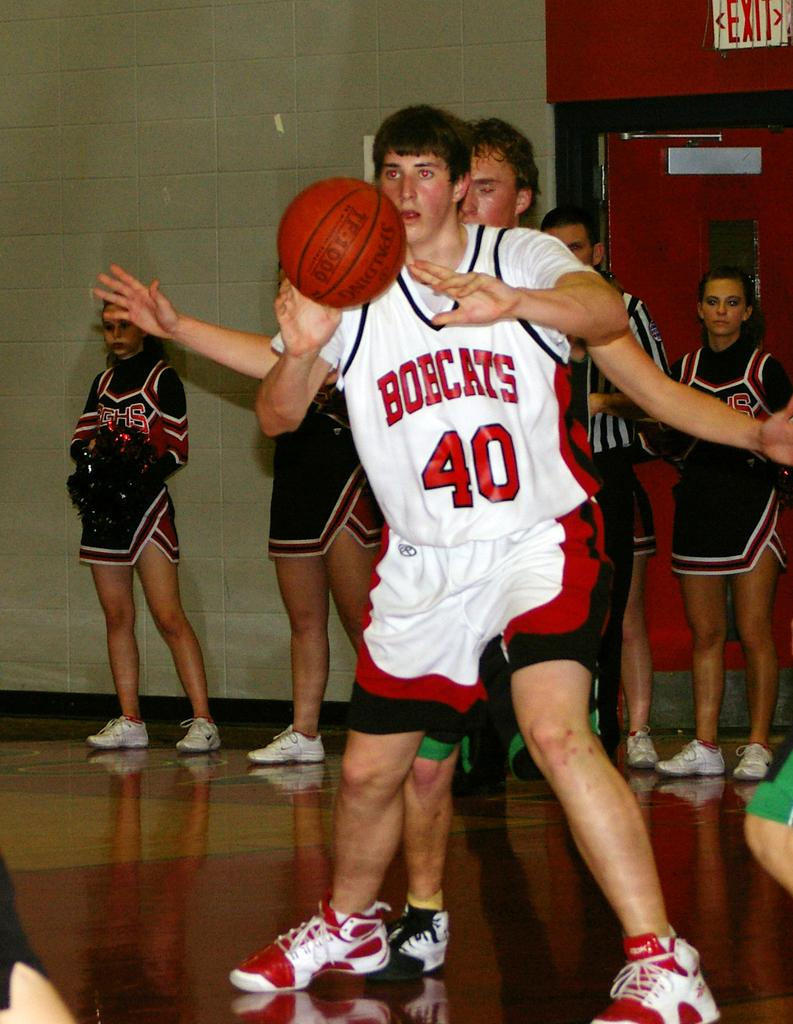<image>
Create a compact narrative representing the image presented. the number 40 is on the basketball jersey 